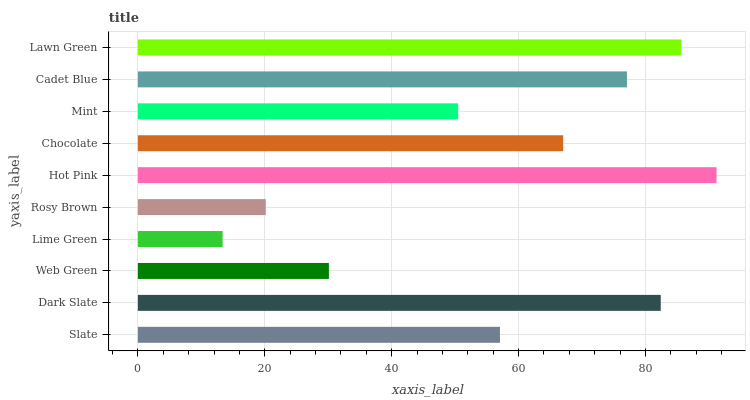Is Lime Green the minimum?
Answer yes or no. Yes. Is Hot Pink the maximum?
Answer yes or no. Yes. Is Dark Slate the minimum?
Answer yes or no. No. Is Dark Slate the maximum?
Answer yes or no. No. Is Dark Slate greater than Slate?
Answer yes or no. Yes. Is Slate less than Dark Slate?
Answer yes or no. Yes. Is Slate greater than Dark Slate?
Answer yes or no. No. Is Dark Slate less than Slate?
Answer yes or no. No. Is Chocolate the high median?
Answer yes or no. Yes. Is Slate the low median?
Answer yes or no. Yes. Is Cadet Blue the high median?
Answer yes or no. No. Is Lime Green the low median?
Answer yes or no. No. 